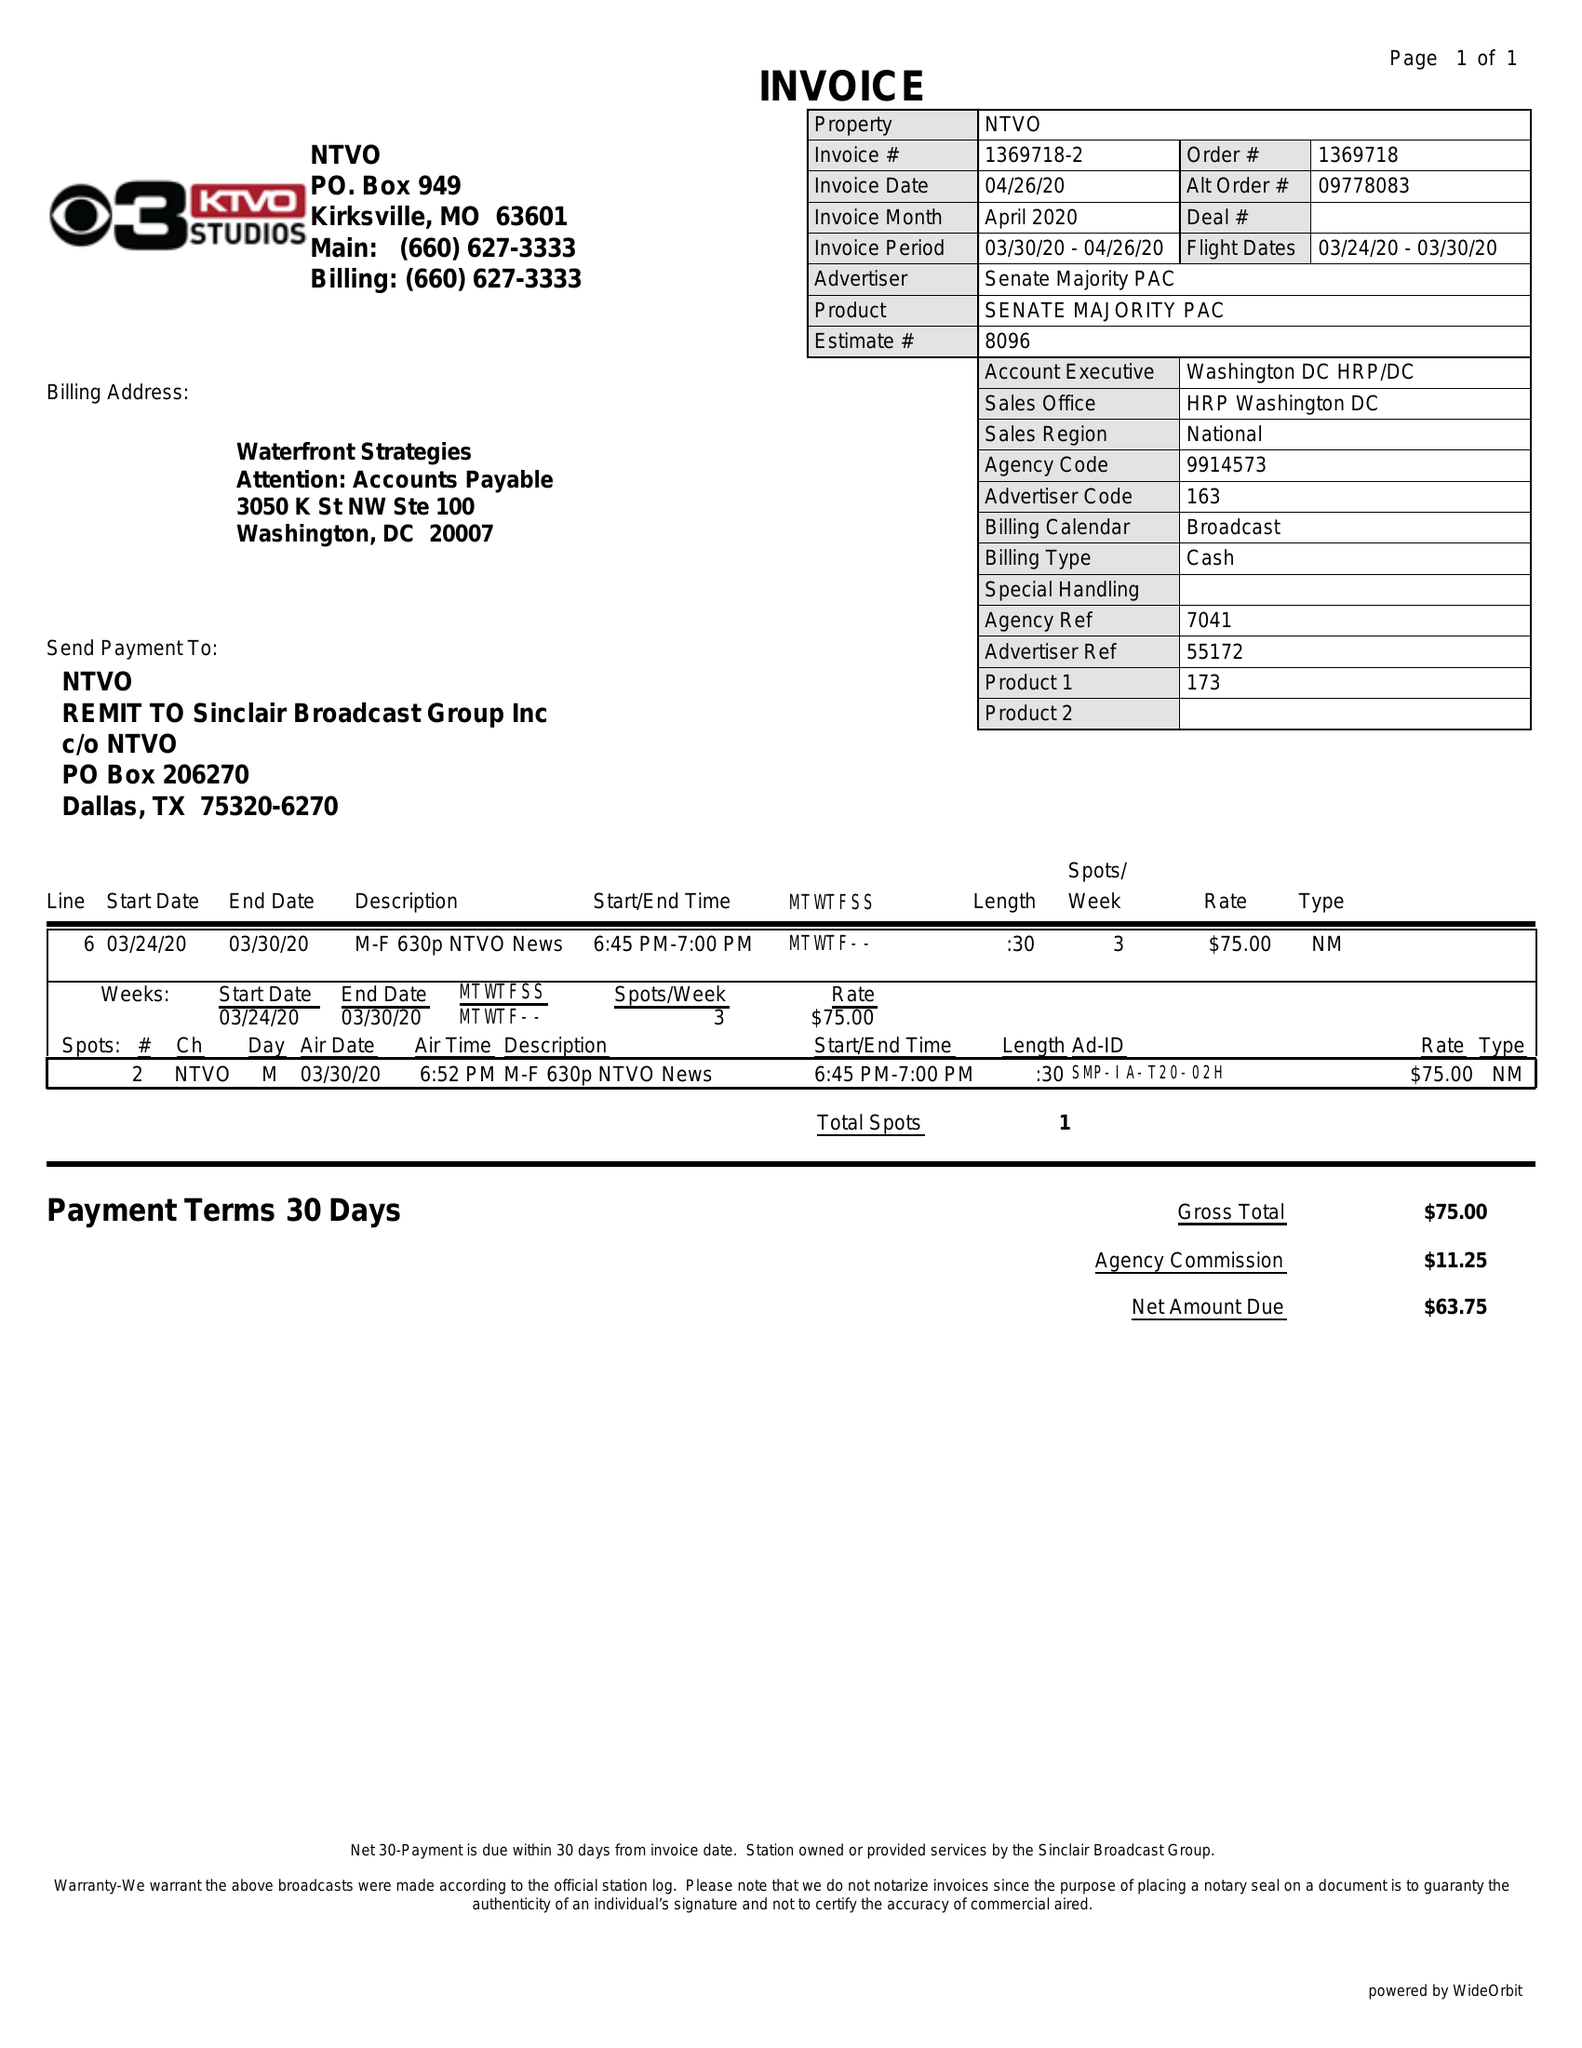What is the value for the contract_num?
Answer the question using a single word or phrase. 1369718 